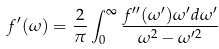Convert formula to latex. <formula><loc_0><loc_0><loc_500><loc_500>f ^ { \prime } ( \omega ) = \frac { 2 } { \pi } \int ^ { \infty } _ { 0 } \frac { f ^ { \prime \prime } ( \omega ^ { \prime } ) \omega ^ { \prime } d \omega ^ { \prime } } { \omega ^ { 2 } - \omega ^ { \prime 2 } }</formula> 